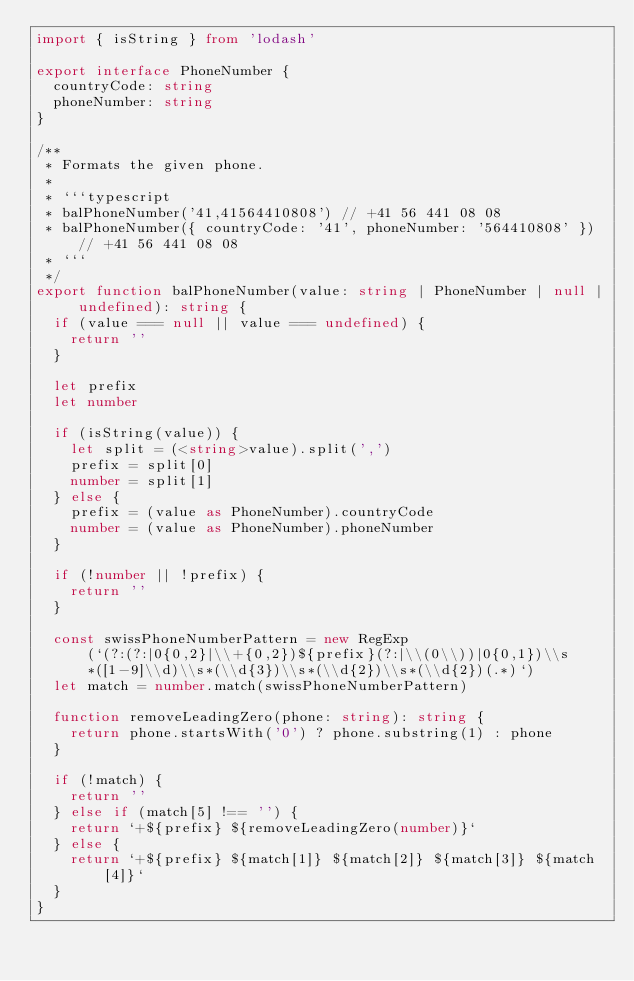Convert code to text. <code><loc_0><loc_0><loc_500><loc_500><_TypeScript_>import { isString } from 'lodash'

export interface PhoneNumber {
  countryCode: string
  phoneNumber: string
}

/**
 * Formats the given phone.
 *
 * ```typescript
 * balPhoneNumber('41,41564410808') // +41 56 441 08 08
 * balPhoneNumber({ countryCode: '41', phoneNumber: '564410808' }) // +41 56 441 08 08
 * ```
 */
export function balPhoneNumber(value: string | PhoneNumber | null | undefined): string {
  if (value === null || value === undefined) {
    return ''
  }

  let prefix
  let number

  if (isString(value)) {
    let split = (<string>value).split(',')
    prefix = split[0]
    number = split[1]
  } else {
    prefix = (value as PhoneNumber).countryCode
    number = (value as PhoneNumber).phoneNumber
  }

  if (!number || !prefix) {
    return ''
  }

  const swissPhoneNumberPattern = new RegExp(`(?:(?:|0{0,2}|\\+{0,2})${prefix}(?:|\\(0\\))|0{0,1})\\s*([1-9]\\d)\\s*(\\d{3})\\s*(\\d{2})\\s*(\\d{2})(.*)`)
  let match = number.match(swissPhoneNumberPattern)

  function removeLeadingZero(phone: string): string {
    return phone.startsWith('0') ? phone.substring(1) : phone
  }

  if (!match) {
    return ''
  } else if (match[5] !== '') {
    return `+${prefix} ${removeLeadingZero(number)}`
  } else {
    return `+${prefix} ${match[1]} ${match[2]} ${match[3]} ${match[4]}`
  }
}
</code> 